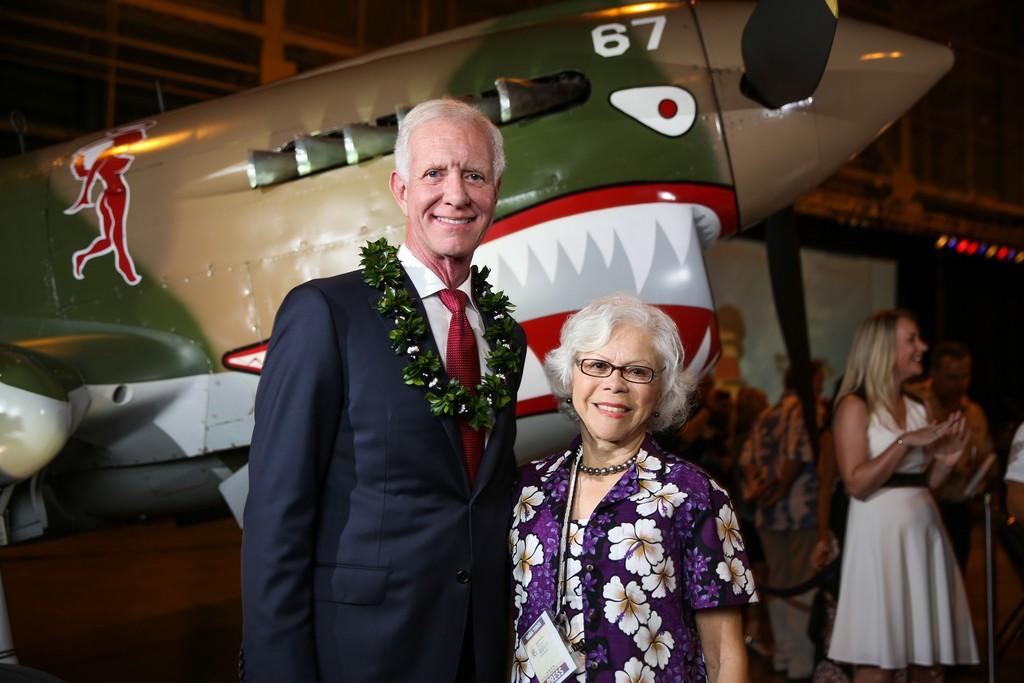<image>
Give a short and clear explanation of the subsequent image. A couple are posing in front of a fighter plane with the number 67 on the nose. 